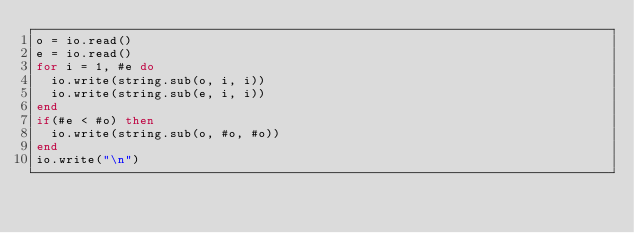Convert code to text. <code><loc_0><loc_0><loc_500><loc_500><_Lua_>o = io.read()
e = io.read()
for i = 1, #e do
  io.write(string.sub(o, i, i))
  io.write(string.sub(e, i, i))
end
if(#e < #o) then
  io.write(string.sub(o, #o, #o))
end
io.write("\n")
</code> 